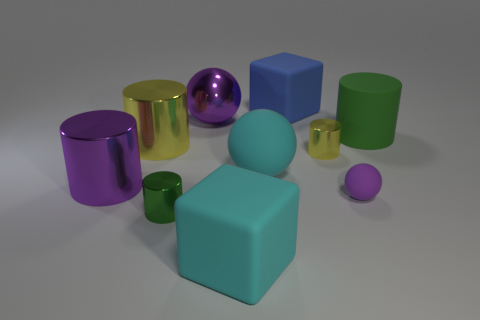How big is the cylinder that is in front of the green rubber cylinder and right of the tiny green object? The cylinder in question appears to be medium-sized in comparison to the other objects around it. It is larger than the tiny green object to its left and smaller than the green rubber cylinder behind it. 